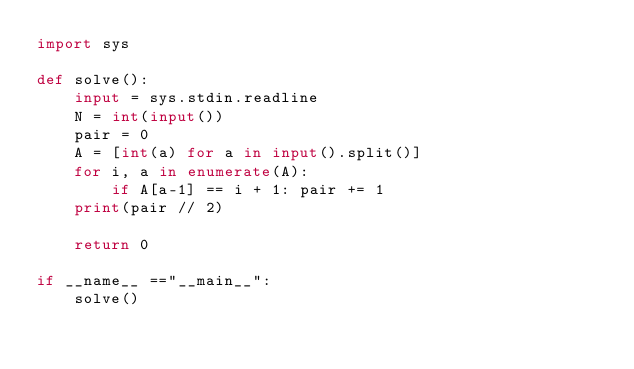Convert code to text. <code><loc_0><loc_0><loc_500><loc_500><_Python_>import sys

def solve():
    input = sys.stdin.readline
    N = int(input())
    pair = 0
    A = [int(a) for a in input().split()]
    for i, a in enumerate(A):
        if A[a-1] == i + 1: pair += 1
    print(pair // 2)

    return 0

if __name__ =="__main__":
    solve()</code> 